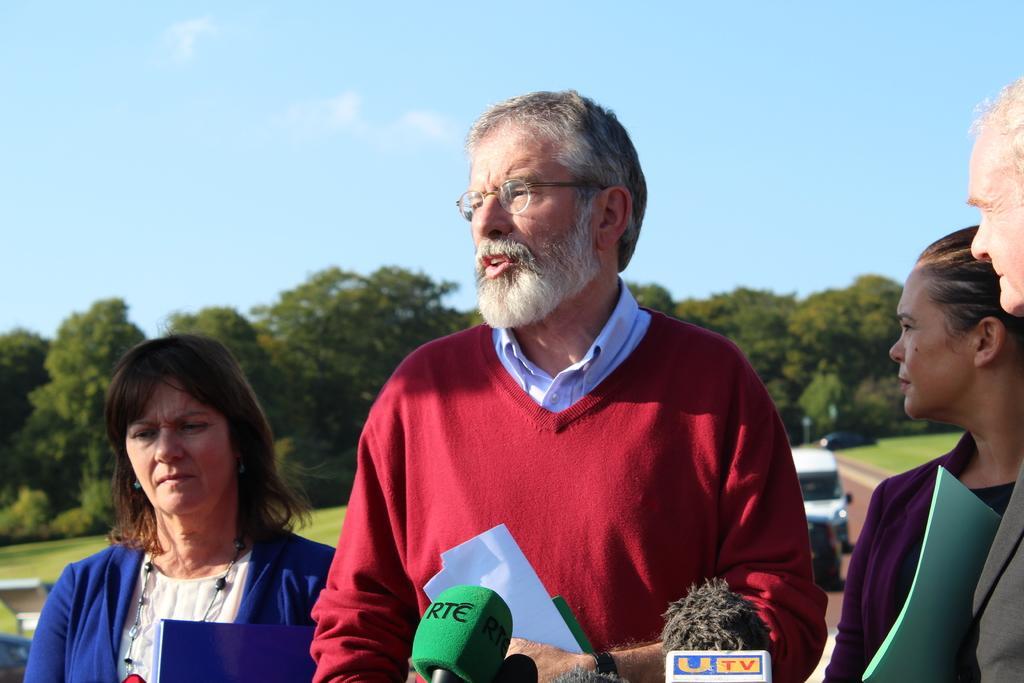Could you give a brief overview of what you see in this image? In the center of the image a man is standing and holding a papers in his hand. On the left and right side of the image some persons are standing. At the bottom of the image mics are there. In the background of the image trees, cars, grass, bench are present. At the top of the image sky is there. 